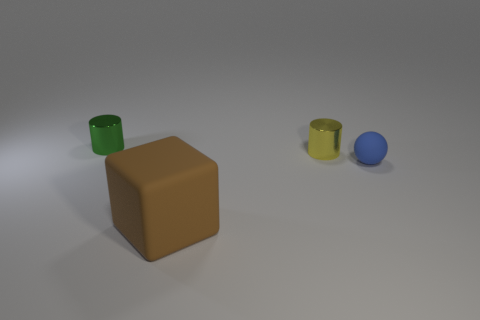Add 3 yellow metal objects. How many objects exist? 7 Subtract all blocks. How many objects are left? 3 Add 1 brown blocks. How many brown blocks are left? 2 Add 4 small green shiny cylinders. How many small green shiny cylinders exist? 5 Subtract 0 yellow cubes. How many objects are left? 4 Subtract all blue rubber spheres. Subtract all tiny metallic cylinders. How many objects are left? 1 